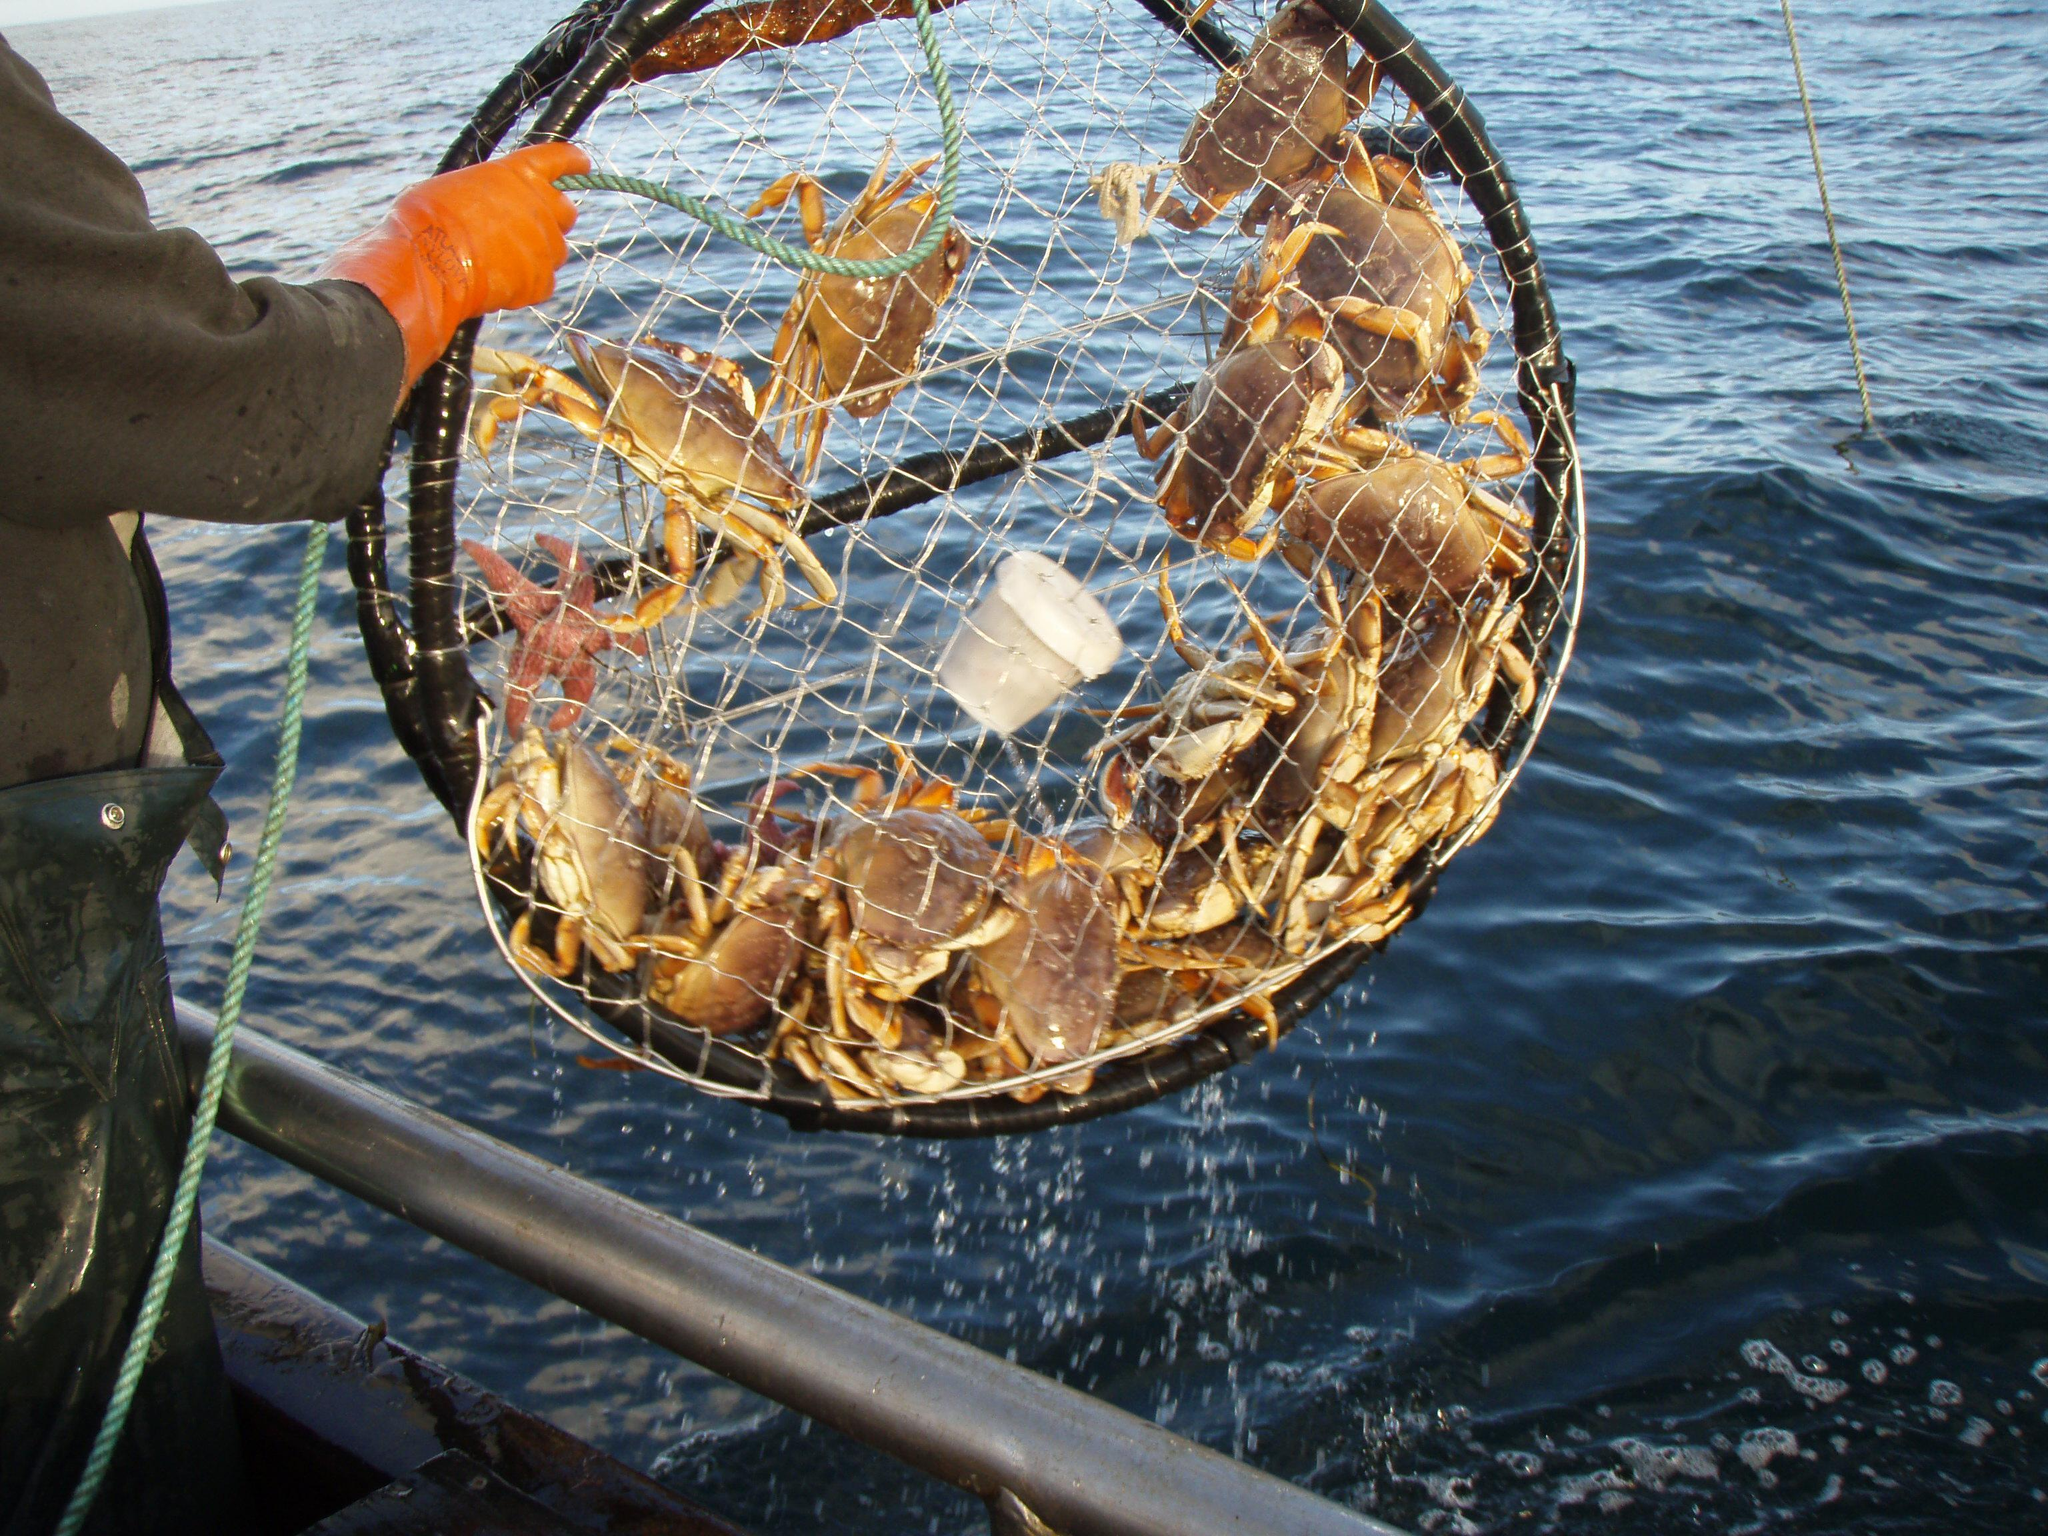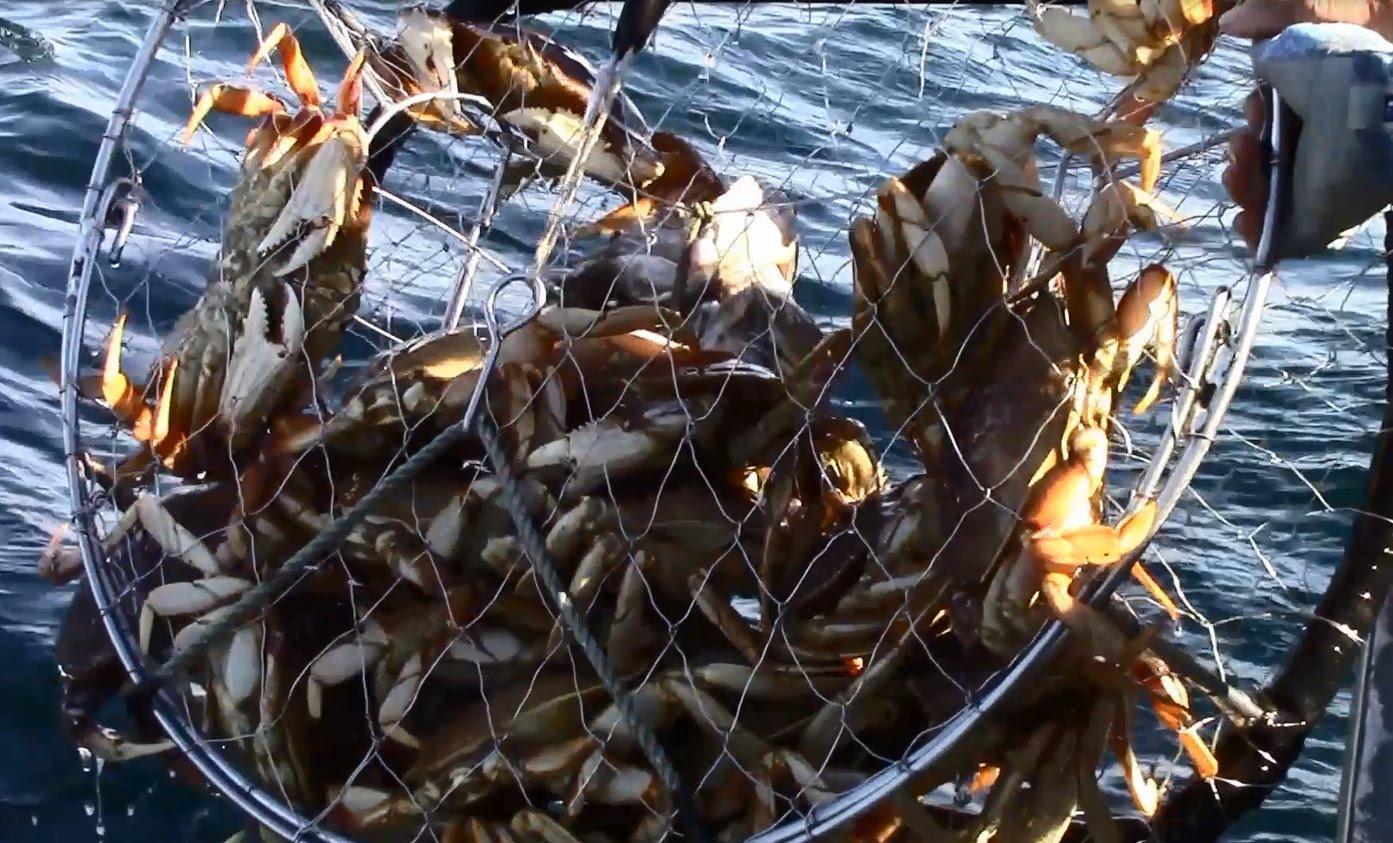The first image is the image on the left, the second image is the image on the right. For the images shown, is this caption "There are crabs in cages." true? Answer yes or no. Yes. The first image is the image on the left, the second image is the image on the right. Analyze the images presented: Is the assertion "At least one image shows crabs in a container with a grid of squares and a metal frame." valid? Answer yes or no. Yes. 